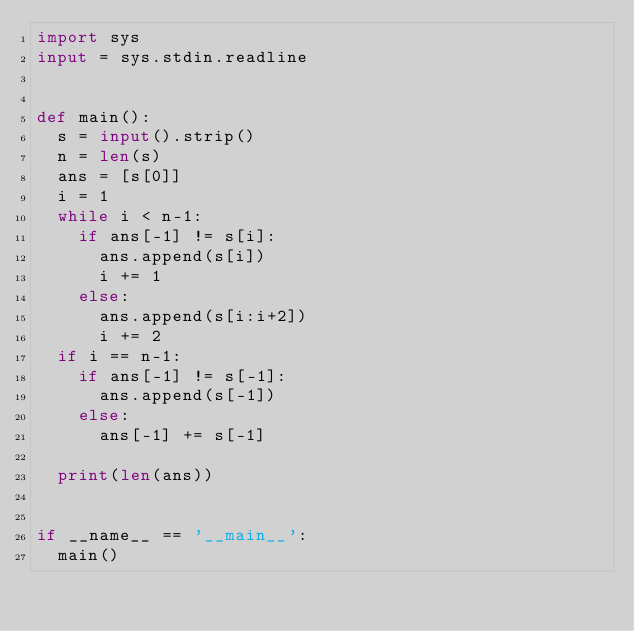<code> <loc_0><loc_0><loc_500><loc_500><_Python_>import sys
input = sys.stdin.readline


def main():
  s = input().strip()
  n = len(s)
  ans = [s[0]]
  i = 1
  while i < n-1:
    if ans[-1] != s[i]:
      ans.append(s[i])
      i += 1
    else:
      ans.append(s[i:i+2])
      i += 2
  if i == n-1:
    if ans[-1] != s[-1]:
      ans.append(s[-1])
    else:
      ans[-1] += s[-1]

  print(len(ans))


if __name__ == '__main__':
  main()
</code> 